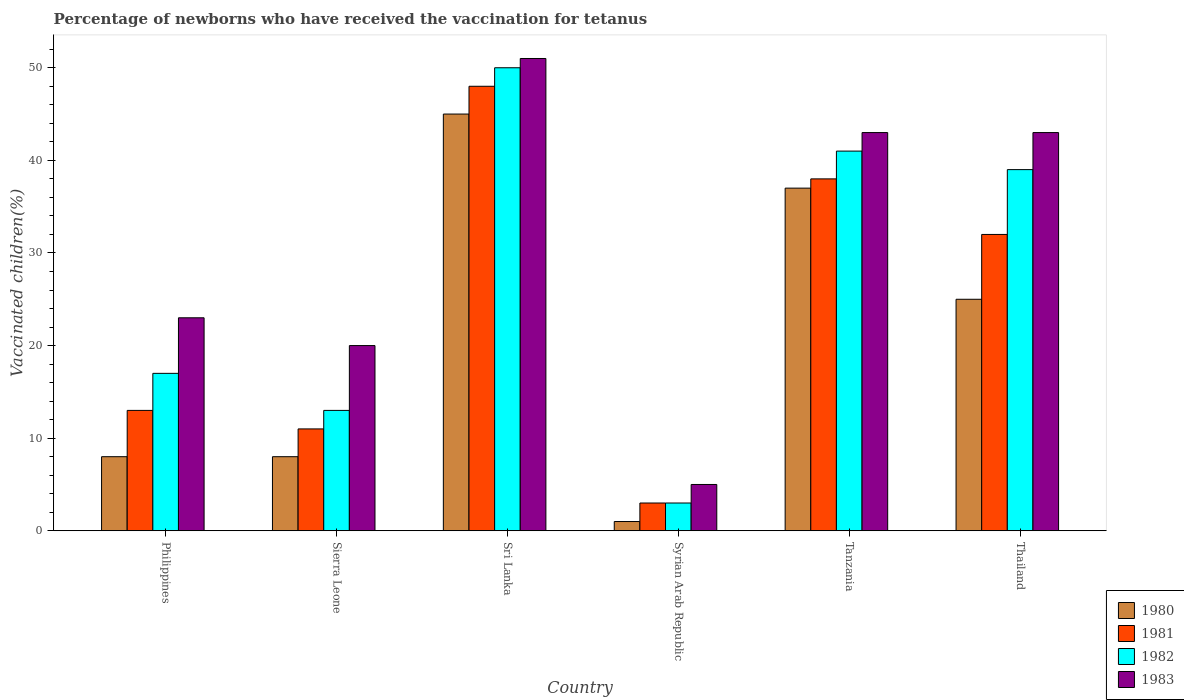Are the number of bars per tick equal to the number of legend labels?
Your response must be concise. Yes. What is the label of the 5th group of bars from the left?
Your response must be concise. Tanzania. In how many cases, is the number of bars for a given country not equal to the number of legend labels?
Ensure brevity in your answer.  0. What is the percentage of vaccinated children in 1980 in Syrian Arab Republic?
Your answer should be compact. 1. Across all countries, what is the minimum percentage of vaccinated children in 1980?
Give a very brief answer. 1. In which country was the percentage of vaccinated children in 1983 maximum?
Make the answer very short. Sri Lanka. In which country was the percentage of vaccinated children in 1983 minimum?
Your answer should be very brief. Syrian Arab Republic. What is the total percentage of vaccinated children in 1980 in the graph?
Offer a terse response. 124. What is the difference between the percentage of vaccinated children in 1981 in Sri Lanka and that in Syrian Arab Republic?
Your answer should be compact. 45. What is the difference between the percentage of vaccinated children in 1982 in Thailand and the percentage of vaccinated children in 1983 in Syrian Arab Republic?
Your answer should be compact. 34. What is the average percentage of vaccinated children in 1982 per country?
Provide a succinct answer. 27.17. In how many countries, is the percentage of vaccinated children in 1983 greater than 48 %?
Keep it short and to the point. 1. What is the ratio of the percentage of vaccinated children in 1983 in Sri Lanka to that in Syrian Arab Republic?
Offer a terse response. 10.2. Is the difference between the percentage of vaccinated children in 1980 in Sierra Leone and Thailand greater than the difference between the percentage of vaccinated children in 1982 in Sierra Leone and Thailand?
Offer a terse response. Yes. Is the sum of the percentage of vaccinated children in 1983 in Sri Lanka and Thailand greater than the maximum percentage of vaccinated children in 1982 across all countries?
Ensure brevity in your answer.  Yes. What does the 2nd bar from the left in Sierra Leone represents?
Give a very brief answer. 1981. What does the 4th bar from the right in Tanzania represents?
Offer a very short reply. 1980. Are the values on the major ticks of Y-axis written in scientific E-notation?
Ensure brevity in your answer.  No. Does the graph contain grids?
Your response must be concise. No. Where does the legend appear in the graph?
Offer a terse response. Bottom right. How many legend labels are there?
Offer a terse response. 4. How are the legend labels stacked?
Offer a very short reply. Vertical. What is the title of the graph?
Ensure brevity in your answer.  Percentage of newborns who have received the vaccination for tetanus. What is the label or title of the Y-axis?
Provide a succinct answer. Vaccinated children(%). What is the Vaccinated children(%) in 1981 in Philippines?
Offer a terse response. 13. What is the Vaccinated children(%) in 1982 in Philippines?
Your answer should be compact. 17. What is the Vaccinated children(%) in 1980 in Sierra Leone?
Your answer should be compact. 8. What is the Vaccinated children(%) of 1981 in Sierra Leone?
Ensure brevity in your answer.  11. What is the Vaccinated children(%) of 1981 in Sri Lanka?
Keep it short and to the point. 48. What is the Vaccinated children(%) in 1983 in Sri Lanka?
Provide a succinct answer. 51. What is the Vaccinated children(%) of 1980 in Syrian Arab Republic?
Offer a very short reply. 1. What is the Vaccinated children(%) of 1982 in Syrian Arab Republic?
Keep it short and to the point. 3. What is the Vaccinated children(%) in 1983 in Syrian Arab Republic?
Provide a succinct answer. 5. What is the Vaccinated children(%) of 1981 in Tanzania?
Provide a short and direct response. 38. What is the Vaccinated children(%) in 1982 in Tanzania?
Provide a succinct answer. 41. What is the Vaccinated children(%) in 1983 in Tanzania?
Keep it short and to the point. 43. What is the Vaccinated children(%) in 1980 in Thailand?
Keep it short and to the point. 25. What is the Vaccinated children(%) of 1981 in Thailand?
Your response must be concise. 32. What is the Vaccinated children(%) of 1983 in Thailand?
Offer a very short reply. 43. Across all countries, what is the maximum Vaccinated children(%) of 1982?
Your response must be concise. 50. Across all countries, what is the maximum Vaccinated children(%) of 1983?
Ensure brevity in your answer.  51. Across all countries, what is the minimum Vaccinated children(%) in 1980?
Your answer should be compact. 1. Across all countries, what is the minimum Vaccinated children(%) of 1981?
Your response must be concise. 3. Across all countries, what is the minimum Vaccinated children(%) in 1982?
Ensure brevity in your answer.  3. What is the total Vaccinated children(%) in 1980 in the graph?
Your answer should be compact. 124. What is the total Vaccinated children(%) in 1981 in the graph?
Your response must be concise. 145. What is the total Vaccinated children(%) in 1982 in the graph?
Your answer should be very brief. 163. What is the total Vaccinated children(%) in 1983 in the graph?
Your response must be concise. 185. What is the difference between the Vaccinated children(%) of 1980 in Philippines and that in Sierra Leone?
Offer a very short reply. 0. What is the difference between the Vaccinated children(%) in 1980 in Philippines and that in Sri Lanka?
Provide a short and direct response. -37. What is the difference between the Vaccinated children(%) of 1981 in Philippines and that in Sri Lanka?
Offer a very short reply. -35. What is the difference between the Vaccinated children(%) of 1982 in Philippines and that in Sri Lanka?
Make the answer very short. -33. What is the difference between the Vaccinated children(%) in 1981 in Philippines and that in Syrian Arab Republic?
Give a very brief answer. 10. What is the difference between the Vaccinated children(%) of 1980 in Philippines and that in Tanzania?
Make the answer very short. -29. What is the difference between the Vaccinated children(%) of 1981 in Philippines and that in Tanzania?
Keep it short and to the point. -25. What is the difference between the Vaccinated children(%) in 1980 in Philippines and that in Thailand?
Provide a short and direct response. -17. What is the difference between the Vaccinated children(%) of 1981 in Philippines and that in Thailand?
Provide a short and direct response. -19. What is the difference between the Vaccinated children(%) in 1982 in Philippines and that in Thailand?
Your response must be concise. -22. What is the difference between the Vaccinated children(%) of 1980 in Sierra Leone and that in Sri Lanka?
Your answer should be compact. -37. What is the difference between the Vaccinated children(%) of 1981 in Sierra Leone and that in Sri Lanka?
Your answer should be compact. -37. What is the difference between the Vaccinated children(%) in 1982 in Sierra Leone and that in Sri Lanka?
Your response must be concise. -37. What is the difference between the Vaccinated children(%) of 1983 in Sierra Leone and that in Sri Lanka?
Make the answer very short. -31. What is the difference between the Vaccinated children(%) in 1983 in Sierra Leone and that in Tanzania?
Ensure brevity in your answer.  -23. What is the difference between the Vaccinated children(%) in 1982 in Sri Lanka and that in Syrian Arab Republic?
Your response must be concise. 47. What is the difference between the Vaccinated children(%) in 1983 in Sri Lanka and that in Syrian Arab Republic?
Your response must be concise. 46. What is the difference between the Vaccinated children(%) of 1982 in Sri Lanka and that in Tanzania?
Offer a very short reply. 9. What is the difference between the Vaccinated children(%) in 1983 in Sri Lanka and that in Tanzania?
Keep it short and to the point. 8. What is the difference between the Vaccinated children(%) of 1980 in Sri Lanka and that in Thailand?
Offer a terse response. 20. What is the difference between the Vaccinated children(%) of 1982 in Sri Lanka and that in Thailand?
Give a very brief answer. 11. What is the difference between the Vaccinated children(%) of 1983 in Sri Lanka and that in Thailand?
Offer a terse response. 8. What is the difference between the Vaccinated children(%) in 1980 in Syrian Arab Republic and that in Tanzania?
Offer a very short reply. -36. What is the difference between the Vaccinated children(%) in 1981 in Syrian Arab Republic and that in Tanzania?
Give a very brief answer. -35. What is the difference between the Vaccinated children(%) of 1982 in Syrian Arab Republic and that in Tanzania?
Give a very brief answer. -38. What is the difference between the Vaccinated children(%) in 1983 in Syrian Arab Republic and that in Tanzania?
Make the answer very short. -38. What is the difference between the Vaccinated children(%) of 1981 in Syrian Arab Republic and that in Thailand?
Give a very brief answer. -29. What is the difference between the Vaccinated children(%) of 1982 in Syrian Arab Republic and that in Thailand?
Your response must be concise. -36. What is the difference between the Vaccinated children(%) in 1983 in Syrian Arab Republic and that in Thailand?
Provide a succinct answer. -38. What is the difference between the Vaccinated children(%) in 1981 in Tanzania and that in Thailand?
Your response must be concise. 6. What is the difference between the Vaccinated children(%) of 1983 in Tanzania and that in Thailand?
Give a very brief answer. 0. What is the difference between the Vaccinated children(%) in 1980 in Philippines and the Vaccinated children(%) in 1981 in Sierra Leone?
Offer a very short reply. -3. What is the difference between the Vaccinated children(%) in 1980 in Philippines and the Vaccinated children(%) in 1982 in Sierra Leone?
Provide a short and direct response. -5. What is the difference between the Vaccinated children(%) of 1982 in Philippines and the Vaccinated children(%) of 1983 in Sierra Leone?
Ensure brevity in your answer.  -3. What is the difference between the Vaccinated children(%) of 1980 in Philippines and the Vaccinated children(%) of 1981 in Sri Lanka?
Your response must be concise. -40. What is the difference between the Vaccinated children(%) of 1980 in Philippines and the Vaccinated children(%) of 1982 in Sri Lanka?
Keep it short and to the point. -42. What is the difference between the Vaccinated children(%) in 1980 in Philippines and the Vaccinated children(%) in 1983 in Sri Lanka?
Your answer should be very brief. -43. What is the difference between the Vaccinated children(%) in 1981 in Philippines and the Vaccinated children(%) in 1982 in Sri Lanka?
Provide a succinct answer. -37. What is the difference between the Vaccinated children(%) of 1981 in Philippines and the Vaccinated children(%) of 1983 in Sri Lanka?
Give a very brief answer. -38. What is the difference between the Vaccinated children(%) in 1982 in Philippines and the Vaccinated children(%) in 1983 in Sri Lanka?
Provide a succinct answer. -34. What is the difference between the Vaccinated children(%) of 1980 in Philippines and the Vaccinated children(%) of 1981 in Syrian Arab Republic?
Keep it short and to the point. 5. What is the difference between the Vaccinated children(%) of 1980 in Philippines and the Vaccinated children(%) of 1982 in Syrian Arab Republic?
Ensure brevity in your answer.  5. What is the difference between the Vaccinated children(%) of 1980 in Philippines and the Vaccinated children(%) of 1983 in Syrian Arab Republic?
Offer a very short reply. 3. What is the difference between the Vaccinated children(%) of 1981 in Philippines and the Vaccinated children(%) of 1983 in Syrian Arab Republic?
Keep it short and to the point. 8. What is the difference between the Vaccinated children(%) in 1980 in Philippines and the Vaccinated children(%) in 1982 in Tanzania?
Ensure brevity in your answer.  -33. What is the difference between the Vaccinated children(%) of 1980 in Philippines and the Vaccinated children(%) of 1983 in Tanzania?
Keep it short and to the point. -35. What is the difference between the Vaccinated children(%) in 1981 in Philippines and the Vaccinated children(%) in 1982 in Tanzania?
Offer a very short reply. -28. What is the difference between the Vaccinated children(%) of 1980 in Philippines and the Vaccinated children(%) of 1982 in Thailand?
Offer a very short reply. -31. What is the difference between the Vaccinated children(%) of 1980 in Philippines and the Vaccinated children(%) of 1983 in Thailand?
Offer a terse response. -35. What is the difference between the Vaccinated children(%) of 1980 in Sierra Leone and the Vaccinated children(%) of 1982 in Sri Lanka?
Make the answer very short. -42. What is the difference between the Vaccinated children(%) in 1980 in Sierra Leone and the Vaccinated children(%) in 1983 in Sri Lanka?
Provide a succinct answer. -43. What is the difference between the Vaccinated children(%) in 1981 in Sierra Leone and the Vaccinated children(%) in 1982 in Sri Lanka?
Offer a very short reply. -39. What is the difference between the Vaccinated children(%) in 1982 in Sierra Leone and the Vaccinated children(%) in 1983 in Sri Lanka?
Your response must be concise. -38. What is the difference between the Vaccinated children(%) of 1980 in Sierra Leone and the Vaccinated children(%) of 1981 in Syrian Arab Republic?
Keep it short and to the point. 5. What is the difference between the Vaccinated children(%) in 1981 in Sierra Leone and the Vaccinated children(%) in 1983 in Syrian Arab Republic?
Make the answer very short. 6. What is the difference between the Vaccinated children(%) of 1982 in Sierra Leone and the Vaccinated children(%) of 1983 in Syrian Arab Republic?
Give a very brief answer. 8. What is the difference between the Vaccinated children(%) in 1980 in Sierra Leone and the Vaccinated children(%) in 1981 in Tanzania?
Give a very brief answer. -30. What is the difference between the Vaccinated children(%) in 1980 in Sierra Leone and the Vaccinated children(%) in 1982 in Tanzania?
Offer a very short reply. -33. What is the difference between the Vaccinated children(%) of 1980 in Sierra Leone and the Vaccinated children(%) of 1983 in Tanzania?
Offer a very short reply. -35. What is the difference between the Vaccinated children(%) in 1981 in Sierra Leone and the Vaccinated children(%) in 1982 in Tanzania?
Your answer should be compact. -30. What is the difference between the Vaccinated children(%) in 1981 in Sierra Leone and the Vaccinated children(%) in 1983 in Tanzania?
Make the answer very short. -32. What is the difference between the Vaccinated children(%) in 1980 in Sierra Leone and the Vaccinated children(%) in 1981 in Thailand?
Provide a short and direct response. -24. What is the difference between the Vaccinated children(%) in 1980 in Sierra Leone and the Vaccinated children(%) in 1982 in Thailand?
Your response must be concise. -31. What is the difference between the Vaccinated children(%) of 1980 in Sierra Leone and the Vaccinated children(%) of 1983 in Thailand?
Ensure brevity in your answer.  -35. What is the difference between the Vaccinated children(%) in 1981 in Sierra Leone and the Vaccinated children(%) in 1982 in Thailand?
Provide a succinct answer. -28. What is the difference between the Vaccinated children(%) of 1981 in Sierra Leone and the Vaccinated children(%) of 1983 in Thailand?
Your response must be concise. -32. What is the difference between the Vaccinated children(%) in 1980 in Sri Lanka and the Vaccinated children(%) in 1981 in Syrian Arab Republic?
Provide a short and direct response. 42. What is the difference between the Vaccinated children(%) of 1980 in Sri Lanka and the Vaccinated children(%) of 1982 in Syrian Arab Republic?
Ensure brevity in your answer.  42. What is the difference between the Vaccinated children(%) of 1981 in Sri Lanka and the Vaccinated children(%) of 1983 in Syrian Arab Republic?
Offer a terse response. 43. What is the difference between the Vaccinated children(%) in 1982 in Sri Lanka and the Vaccinated children(%) in 1983 in Syrian Arab Republic?
Offer a very short reply. 45. What is the difference between the Vaccinated children(%) in 1980 in Sri Lanka and the Vaccinated children(%) in 1982 in Tanzania?
Make the answer very short. 4. What is the difference between the Vaccinated children(%) in 1980 in Sri Lanka and the Vaccinated children(%) in 1982 in Thailand?
Ensure brevity in your answer.  6. What is the difference between the Vaccinated children(%) of 1980 in Sri Lanka and the Vaccinated children(%) of 1983 in Thailand?
Your answer should be compact. 2. What is the difference between the Vaccinated children(%) of 1982 in Sri Lanka and the Vaccinated children(%) of 1983 in Thailand?
Provide a succinct answer. 7. What is the difference between the Vaccinated children(%) of 1980 in Syrian Arab Republic and the Vaccinated children(%) of 1981 in Tanzania?
Keep it short and to the point. -37. What is the difference between the Vaccinated children(%) of 1980 in Syrian Arab Republic and the Vaccinated children(%) of 1982 in Tanzania?
Give a very brief answer. -40. What is the difference between the Vaccinated children(%) of 1980 in Syrian Arab Republic and the Vaccinated children(%) of 1983 in Tanzania?
Offer a very short reply. -42. What is the difference between the Vaccinated children(%) of 1981 in Syrian Arab Republic and the Vaccinated children(%) of 1982 in Tanzania?
Provide a succinct answer. -38. What is the difference between the Vaccinated children(%) in 1980 in Syrian Arab Republic and the Vaccinated children(%) in 1981 in Thailand?
Ensure brevity in your answer.  -31. What is the difference between the Vaccinated children(%) of 1980 in Syrian Arab Republic and the Vaccinated children(%) of 1982 in Thailand?
Provide a short and direct response. -38. What is the difference between the Vaccinated children(%) in 1980 in Syrian Arab Republic and the Vaccinated children(%) in 1983 in Thailand?
Your response must be concise. -42. What is the difference between the Vaccinated children(%) of 1981 in Syrian Arab Republic and the Vaccinated children(%) of 1982 in Thailand?
Your answer should be very brief. -36. What is the difference between the Vaccinated children(%) in 1981 in Syrian Arab Republic and the Vaccinated children(%) in 1983 in Thailand?
Make the answer very short. -40. What is the difference between the Vaccinated children(%) in 1980 in Tanzania and the Vaccinated children(%) in 1981 in Thailand?
Your response must be concise. 5. What is the difference between the Vaccinated children(%) in 1980 in Tanzania and the Vaccinated children(%) in 1983 in Thailand?
Offer a very short reply. -6. What is the difference between the Vaccinated children(%) in 1982 in Tanzania and the Vaccinated children(%) in 1983 in Thailand?
Offer a very short reply. -2. What is the average Vaccinated children(%) in 1980 per country?
Your response must be concise. 20.67. What is the average Vaccinated children(%) in 1981 per country?
Your answer should be very brief. 24.17. What is the average Vaccinated children(%) of 1982 per country?
Offer a terse response. 27.17. What is the average Vaccinated children(%) in 1983 per country?
Ensure brevity in your answer.  30.83. What is the difference between the Vaccinated children(%) in 1980 and Vaccinated children(%) in 1983 in Philippines?
Keep it short and to the point. -15. What is the difference between the Vaccinated children(%) of 1981 and Vaccinated children(%) of 1982 in Philippines?
Your answer should be very brief. -4. What is the difference between the Vaccinated children(%) in 1981 and Vaccinated children(%) in 1983 in Philippines?
Give a very brief answer. -10. What is the difference between the Vaccinated children(%) in 1980 and Vaccinated children(%) in 1982 in Sierra Leone?
Make the answer very short. -5. What is the difference between the Vaccinated children(%) of 1980 and Vaccinated children(%) of 1983 in Sierra Leone?
Your response must be concise. -12. What is the difference between the Vaccinated children(%) in 1981 and Vaccinated children(%) in 1983 in Sri Lanka?
Provide a succinct answer. -3. What is the difference between the Vaccinated children(%) of 1982 and Vaccinated children(%) of 1983 in Sri Lanka?
Your answer should be very brief. -1. What is the difference between the Vaccinated children(%) in 1980 and Vaccinated children(%) in 1981 in Syrian Arab Republic?
Ensure brevity in your answer.  -2. What is the difference between the Vaccinated children(%) of 1980 and Vaccinated children(%) of 1982 in Syrian Arab Republic?
Provide a short and direct response. -2. What is the difference between the Vaccinated children(%) of 1980 and Vaccinated children(%) of 1983 in Syrian Arab Republic?
Provide a succinct answer. -4. What is the difference between the Vaccinated children(%) in 1981 and Vaccinated children(%) in 1983 in Syrian Arab Republic?
Offer a very short reply. -2. What is the difference between the Vaccinated children(%) of 1982 and Vaccinated children(%) of 1983 in Syrian Arab Republic?
Make the answer very short. -2. What is the difference between the Vaccinated children(%) of 1981 and Vaccinated children(%) of 1982 in Tanzania?
Offer a very short reply. -3. What is the difference between the Vaccinated children(%) of 1980 and Vaccinated children(%) of 1982 in Thailand?
Ensure brevity in your answer.  -14. What is the difference between the Vaccinated children(%) of 1980 and Vaccinated children(%) of 1983 in Thailand?
Your response must be concise. -18. What is the difference between the Vaccinated children(%) of 1981 and Vaccinated children(%) of 1982 in Thailand?
Give a very brief answer. -7. What is the difference between the Vaccinated children(%) in 1981 and Vaccinated children(%) in 1983 in Thailand?
Provide a succinct answer. -11. What is the ratio of the Vaccinated children(%) of 1980 in Philippines to that in Sierra Leone?
Your answer should be compact. 1. What is the ratio of the Vaccinated children(%) in 1981 in Philippines to that in Sierra Leone?
Give a very brief answer. 1.18. What is the ratio of the Vaccinated children(%) of 1982 in Philippines to that in Sierra Leone?
Keep it short and to the point. 1.31. What is the ratio of the Vaccinated children(%) of 1983 in Philippines to that in Sierra Leone?
Ensure brevity in your answer.  1.15. What is the ratio of the Vaccinated children(%) in 1980 in Philippines to that in Sri Lanka?
Provide a succinct answer. 0.18. What is the ratio of the Vaccinated children(%) in 1981 in Philippines to that in Sri Lanka?
Offer a terse response. 0.27. What is the ratio of the Vaccinated children(%) of 1982 in Philippines to that in Sri Lanka?
Your response must be concise. 0.34. What is the ratio of the Vaccinated children(%) in 1983 in Philippines to that in Sri Lanka?
Offer a very short reply. 0.45. What is the ratio of the Vaccinated children(%) of 1980 in Philippines to that in Syrian Arab Republic?
Offer a very short reply. 8. What is the ratio of the Vaccinated children(%) in 1981 in Philippines to that in Syrian Arab Republic?
Your response must be concise. 4.33. What is the ratio of the Vaccinated children(%) of 1982 in Philippines to that in Syrian Arab Republic?
Keep it short and to the point. 5.67. What is the ratio of the Vaccinated children(%) of 1980 in Philippines to that in Tanzania?
Make the answer very short. 0.22. What is the ratio of the Vaccinated children(%) of 1981 in Philippines to that in Tanzania?
Your answer should be very brief. 0.34. What is the ratio of the Vaccinated children(%) of 1982 in Philippines to that in Tanzania?
Give a very brief answer. 0.41. What is the ratio of the Vaccinated children(%) of 1983 in Philippines to that in Tanzania?
Offer a terse response. 0.53. What is the ratio of the Vaccinated children(%) in 1980 in Philippines to that in Thailand?
Your answer should be compact. 0.32. What is the ratio of the Vaccinated children(%) of 1981 in Philippines to that in Thailand?
Offer a terse response. 0.41. What is the ratio of the Vaccinated children(%) of 1982 in Philippines to that in Thailand?
Provide a succinct answer. 0.44. What is the ratio of the Vaccinated children(%) of 1983 in Philippines to that in Thailand?
Provide a succinct answer. 0.53. What is the ratio of the Vaccinated children(%) of 1980 in Sierra Leone to that in Sri Lanka?
Give a very brief answer. 0.18. What is the ratio of the Vaccinated children(%) in 1981 in Sierra Leone to that in Sri Lanka?
Offer a terse response. 0.23. What is the ratio of the Vaccinated children(%) in 1982 in Sierra Leone to that in Sri Lanka?
Give a very brief answer. 0.26. What is the ratio of the Vaccinated children(%) in 1983 in Sierra Leone to that in Sri Lanka?
Your answer should be very brief. 0.39. What is the ratio of the Vaccinated children(%) of 1981 in Sierra Leone to that in Syrian Arab Republic?
Give a very brief answer. 3.67. What is the ratio of the Vaccinated children(%) in 1982 in Sierra Leone to that in Syrian Arab Republic?
Provide a succinct answer. 4.33. What is the ratio of the Vaccinated children(%) in 1980 in Sierra Leone to that in Tanzania?
Provide a succinct answer. 0.22. What is the ratio of the Vaccinated children(%) in 1981 in Sierra Leone to that in Tanzania?
Ensure brevity in your answer.  0.29. What is the ratio of the Vaccinated children(%) of 1982 in Sierra Leone to that in Tanzania?
Offer a terse response. 0.32. What is the ratio of the Vaccinated children(%) of 1983 in Sierra Leone to that in Tanzania?
Make the answer very short. 0.47. What is the ratio of the Vaccinated children(%) in 1980 in Sierra Leone to that in Thailand?
Make the answer very short. 0.32. What is the ratio of the Vaccinated children(%) in 1981 in Sierra Leone to that in Thailand?
Offer a terse response. 0.34. What is the ratio of the Vaccinated children(%) of 1983 in Sierra Leone to that in Thailand?
Keep it short and to the point. 0.47. What is the ratio of the Vaccinated children(%) in 1980 in Sri Lanka to that in Syrian Arab Republic?
Make the answer very short. 45. What is the ratio of the Vaccinated children(%) of 1982 in Sri Lanka to that in Syrian Arab Republic?
Provide a succinct answer. 16.67. What is the ratio of the Vaccinated children(%) of 1983 in Sri Lanka to that in Syrian Arab Republic?
Provide a succinct answer. 10.2. What is the ratio of the Vaccinated children(%) in 1980 in Sri Lanka to that in Tanzania?
Provide a short and direct response. 1.22. What is the ratio of the Vaccinated children(%) of 1981 in Sri Lanka to that in Tanzania?
Your answer should be compact. 1.26. What is the ratio of the Vaccinated children(%) of 1982 in Sri Lanka to that in Tanzania?
Keep it short and to the point. 1.22. What is the ratio of the Vaccinated children(%) in 1983 in Sri Lanka to that in Tanzania?
Your answer should be very brief. 1.19. What is the ratio of the Vaccinated children(%) of 1981 in Sri Lanka to that in Thailand?
Offer a terse response. 1.5. What is the ratio of the Vaccinated children(%) of 1982 in Sri Lanka to that in Thailand?
Offer a terse response. 1.28. What is the ratio of the Vaccinated children(%) of 1983 in Sri Lanka to that in Thailand?
Ensure brevity in your answer.  1.19. What is the ratio of the Vaccinated children(%) of 1980 in Syrian Arab Republic to that in Tanzania?
Your answer should be compact. 0.03. What is the ratio of the Vaccinated children(%) of 1981 in Syrian Arab Republic to that in Tanzania?
Ensure brevity in your answer.  0.08. What is the ratio of the Vaccinated children(%) in 1982 in Syrian Arab Republic to that in Tanzania?
Provide a succinct answer. 0.07. What is the ratio of the Vaccinated children(%) in 1983 in Syrian Arab Republic to that in Tanzania?
Ensure brevity in your answer.  0.12. What is the ratio of the Vaccinated children(%) in 1980 in Syrian Arab Republic to that in Thailand?
Offer a very short reply. 0.04. What is the ratio of the Vaccinated children(%) of 1981 in Syrian Arab Republic to that in Thailand?
Provide a short and direct response. 0.09. What is the ratio of the Vaccinated children(%) of 1982 in Syrian Arab Republic to that in Thailand?
Provide a short and direct response. 0.08. What is the ratio of the Vaccinated children(%) of 1983 in Syrian Arab Republic to that in Thailand?
Your response must be concise. 0.12. What is the ratio of the Vaccinated children(%) in 1980 in Tanzania to that in Thailand?
Make the answer very short. 1.48. What is the ratio of the Vaccinated children(%) in 1981 in Tanzania to that in Thailand?
Offer a very short reply. 1.19. What is the ratio of the Vaccinated children(%) in 1982 in Tanzania to that in Thailand?
Your response must be concise. 1.05. What is the difference between the highest and the second highest Vaccinated children(%) in 1981?
Ensure brevity in your answer.  10. What is the difference between the highest and the second highest Vaccinated children(%) of 1983?
Provide a short and direct response. 8. What is the difference between the highest and the lowest Vaccinated children(%) of 1980?
Give a very brief answer. 44. What is the difference between the highest and the lowest Vaccinated children(%) in 1981?
Offer a terse response. 45. What is the difference between the highest and the lowest Vaccinated children(%) in 1983?
Make the answer very short. 46. 